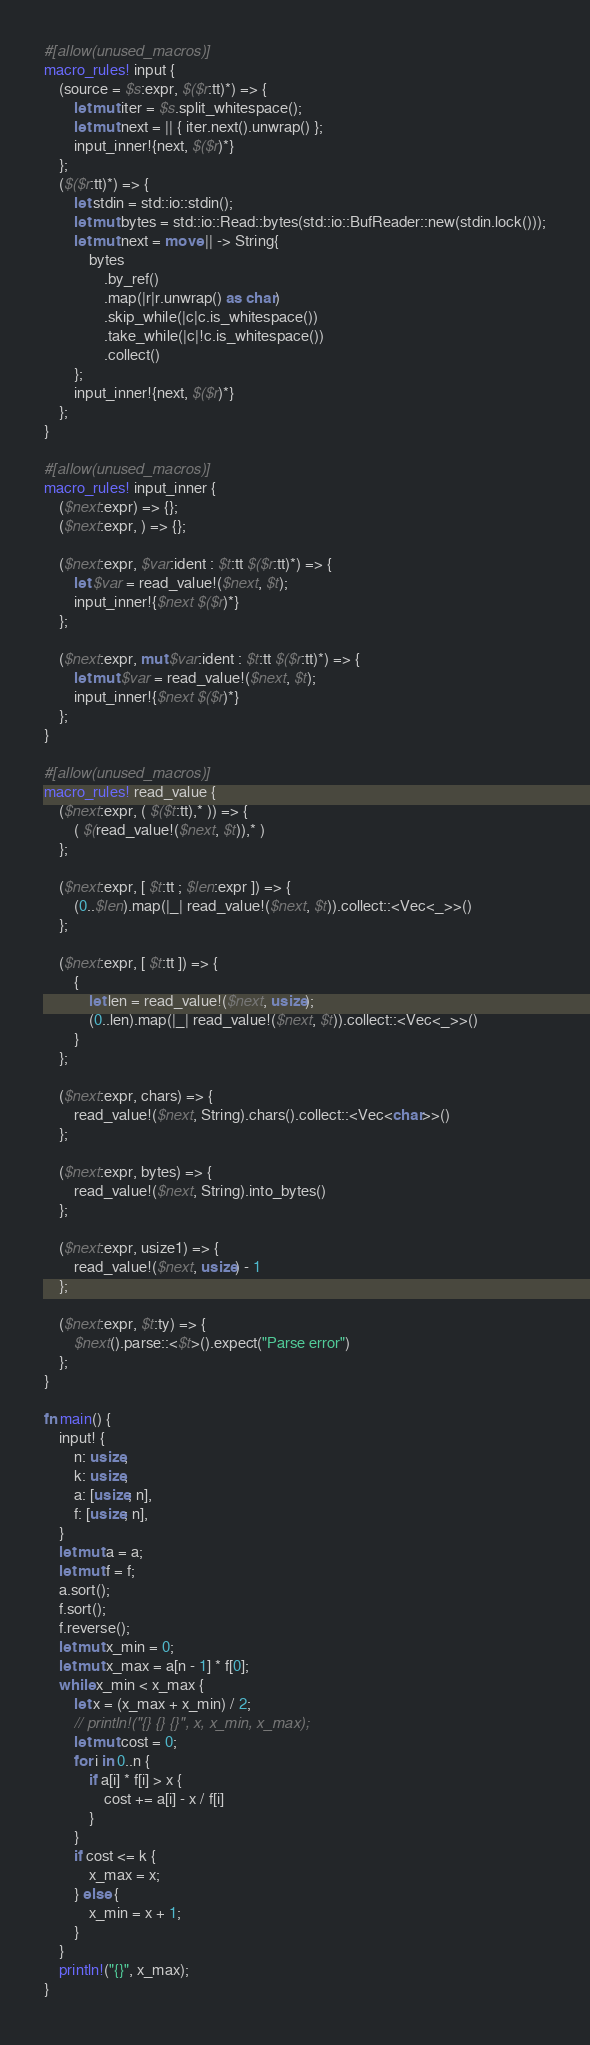Convert code to text. <code><loc_0><loc_0><loc_500><loc_500><_Rust_>#[allow(unused_macros)]
macro_rules! input {
    (source = $s:expr, $($r:tt)*) => {
        let mut iter = $s.split_whitespace();
        let mut next = || { iter.next().unwrap() };
        input_inner!{next, $($r)*}
    };
    ($($r:tt)*) => {
        let stdin = std::io::stdin();
        let mut bytes = std::io::Read::bytes(std::io::BufReader::new(stdin.lock()));
        let mut next = move || -> String{
            bytes
                .by_ref()
                .map(|r|r.unwrap() as char)
                .skip_while(|c|c.is_whitespace())
                .take_while(|c|!c.is_whitespace())
                .collect()
        };
        input_inner!{next, $($r)*}
    };
}

#[allow(unused_macros)]
macro_rules! input_inner {
    ($next:expr) => {};
    ($next:expr, ) => {};

    ($next:expr, $var:ident : $t:tt $($r:tt)*) => {
        let $var = read_value!($next, $t);
        input_inner!{$next $($r)*}
    };

    ($next:expr, mut $var:ident : $t:tt $($r:tt)*) => {
        let mut $var = read_value!($next, $t);
        input_inner!{$next $($r)*}
    };
}

#[allow(unused_macros)]
macro_rules! read_value {
    ($next:expr, ( $($t:tt),* )) => {
        ( $(read_value!($next, $t)),* )
    };

    ($next:expr, [ $t:tt ; $len:expr ]) => {
        (0..$len).map(|_| read_value!($next, $t)).collect::<Vec<_>>()
    };

    ($next:expr, [ $t:tt ]) => {
        {
            let len = read_value!($next, usize);
            (0..len).map(|_| read_value!($next, $t)).collect::<Vec<_>>()
        }
    };

    ($next:expr, chars) => {
        read_value!($next, String).chars().collect::<Vec<char>>()
    };

    ($next:expr, bytes) => {
        read_value!($next, String).into_bytes()
    };

    ($next:expr, usize1) => {
        read_value!($next, usize) - 1
    };

    ($next:expr, $t:ty) => {
        $next().parse::<$t>().expect("Parse error")
    };
}

fn main() {
    input! {
        n: usize,
        k: usize,
        a: [usize; n],
        f: [usize; n],
    }
    let mut a = a;
    let mut f = f;
    a.sort();
    f.sort();
    f.reverse();
    let mut x_min = 0;
    let mut x_max = a[n - 1] * f[0];
    while x_min < x_max {
        let x = (x_max + x_min) / 2;
        // println!("{} {} {}", x, x_min, x_max);
        let mut cost = 0;
        for i in 0..n {
            if a[i] * f[i] > x {
                cost += a[i] - x / f[i]
            }
        }
        if cost <= k {
            x_max = x;
        } else {
            x_min = x + 1;
        }
    }
    println!("{}", x_max);
}
</code> 